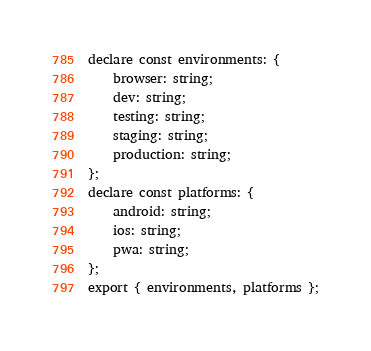<code> <loc_0><loc_0><loc_500><loc_500><_TypeScript_>declare const environments: {
    browser: string;
    dev: string;
    testing: string;
    staging: string;
    production: string;
};
declare const platforms: {
    android: string;
    ios: string;
    pwa: string;
};
export { environments, platforms };
</code> 